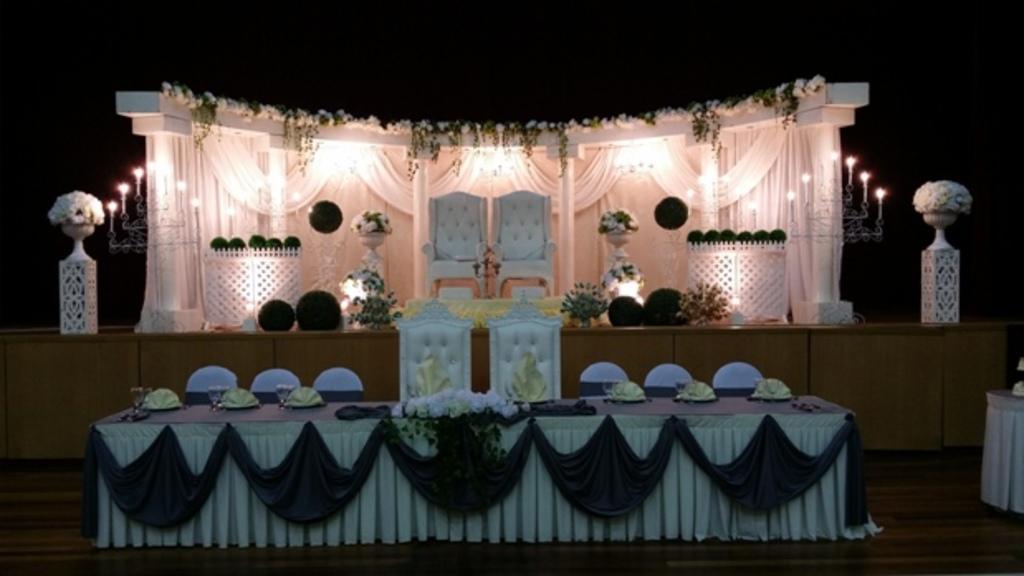Describe this image in one or two sentences. In this picture there is a stage decorated with white color curtains and flowers. There are some green color balls on stage, In front of it there are two white colored chairs. Beside the declaration there is a pot with white color flowers and a stand with lights. And in the bottom there is a table with curtains decorated on it. 